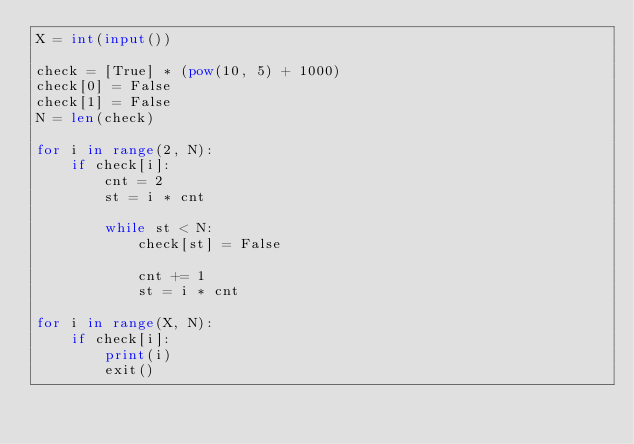Convert code to text. <code><loc_0><loc_0><loc_500><loc_500><_Python_>X = int(input())

check = [True] * (pow(10, 5) + 1000)
check[0] = False
check[1] = False
N = len(check)

for i in range(2, N):
    if check[i]:
        cnt = 2
        st = i * cnt

        while st < N:
            check[st] = False

            cnt += 1
            st = i * cnt

for i in range(X, N):
    if check[i]:
        print(i)
        exit()
</code> 